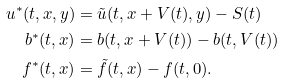<formula> <loc_0><loc_0><loc_500><loc_500>u ^ { * } ( t , x , y ) & = \tilde { u } ( t , x + V ( t ) , y ) - S ( t ) \\ b ^ { * } ( t , x ) & = b ( t , x + V ( t ) ) - b ( t , V ( t ) ) \\ f ^ { * } ( t , x ) & = \tilde { f } ( t , x ) - f ( t , 0 ) .</formula> 